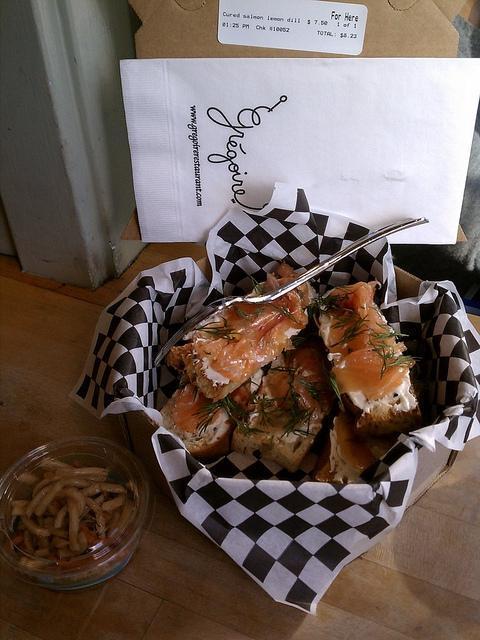The basket of salmon is currently being eaten at which location?
From the following set of four choices, select the accurate answer to respond to the question.
Options: Restaurant, car, work, home. Restaurant. 